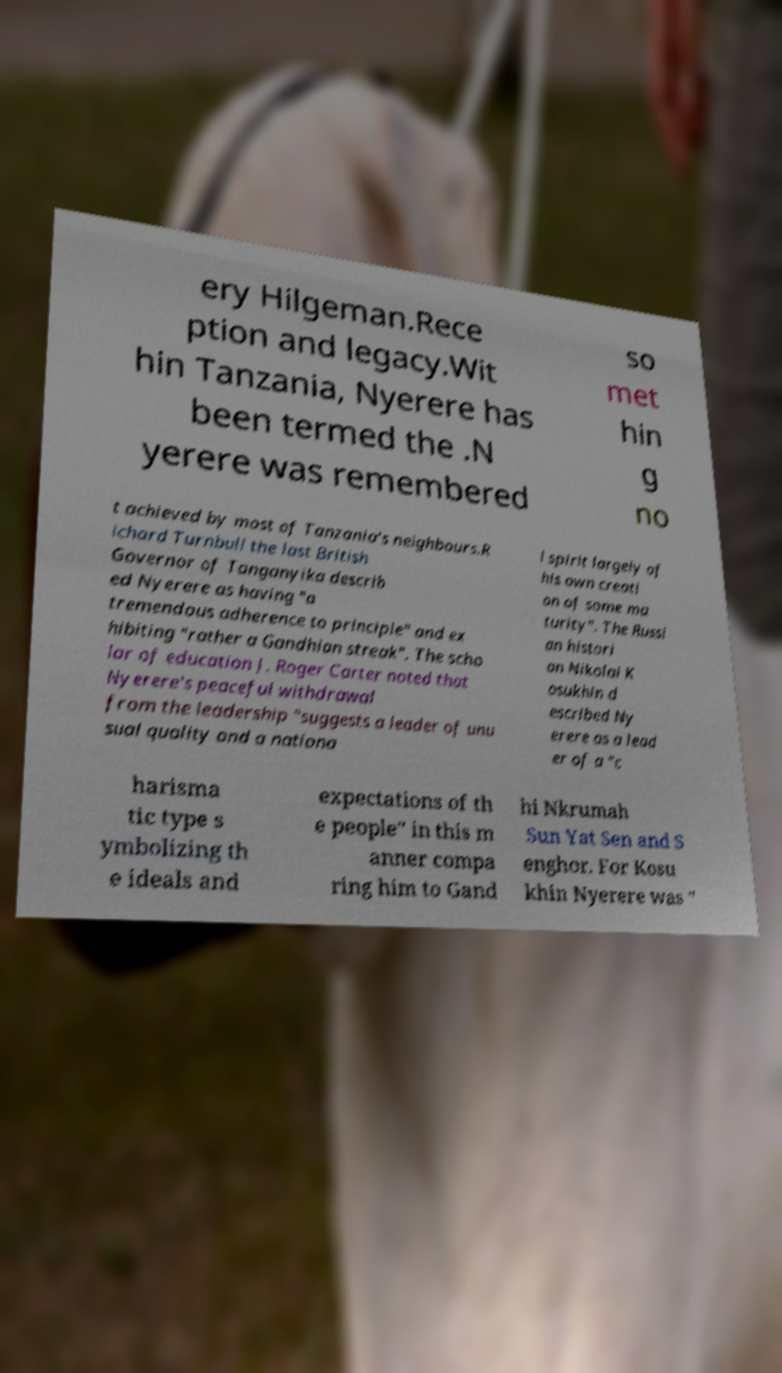Can you accurately transcribe the text from the provided image for me? ery Hilgeman.Rece ption and legacy.Wit hin Tanzania, Nyerere has been termed the .N yerere was remembered so met hin g no t achieved by most of Tanzania's neighbours.R ichard Turnbull the last British Governor of Tanganyika describ ed Nyerere as having "a tremendous adherence to principle" and ex hibiting "rather a Gandhian streak". The scho lar of education J. Roger Carter noted that Nyerere's peaceful withdrawal from the leadership "suggests a leader of unu sual quality and a nationa l spirit largely of his own creati on of some ma turity". The Russi an histori an Nikolai K osukhin d escribed Ny erere as a lead er of a "c harisma tic type s ymbolizing th e ideals and expectations of th e people" in this m anner compa ring him to Gand hi Nkrumah Sun Yat Sen and S enghor. For Kosu khin Nyerere was " 